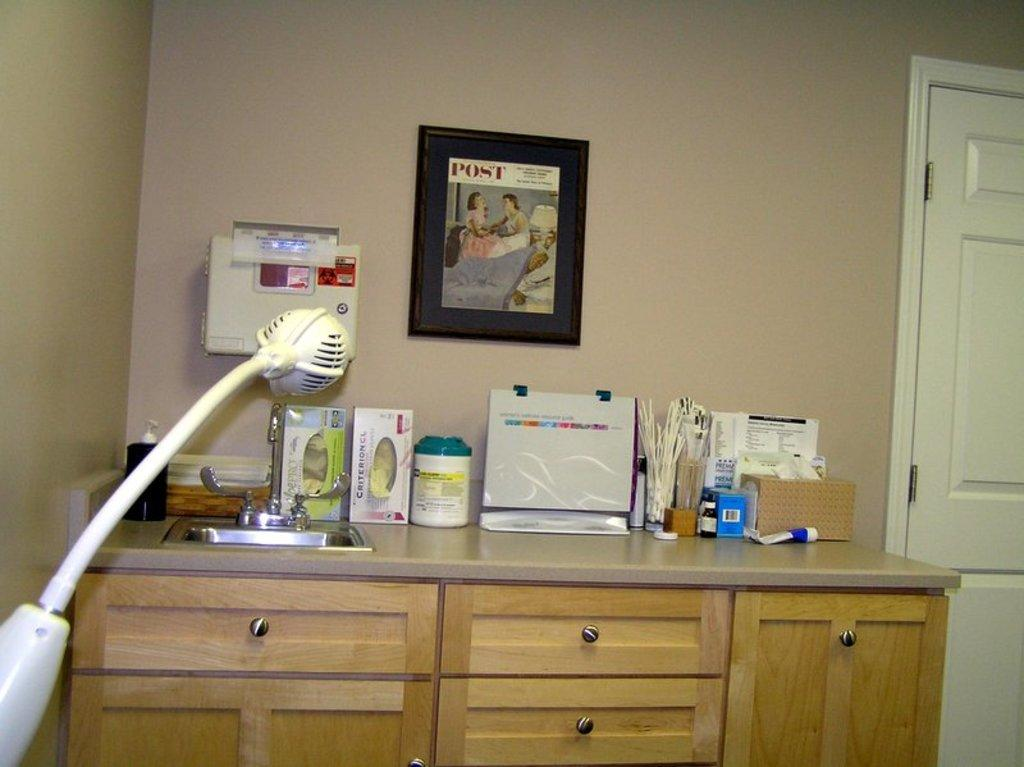What can be seen near the sink in the image? There is a tap near the sink in the image. What is on the table in the image? There is a bottle and unspecified things on the table in the image. What is attached to the wall in the image? A photo is attached to a wall in the image. What type of furniture is present in the image? There is a door and a desk in the image. What type of beam is holding up the ceiling in the image? There is no mention of a beam or a ceiling in the image. What kind of bait is being used to catch fish in the image? There is no fishing or bait present in the image. 